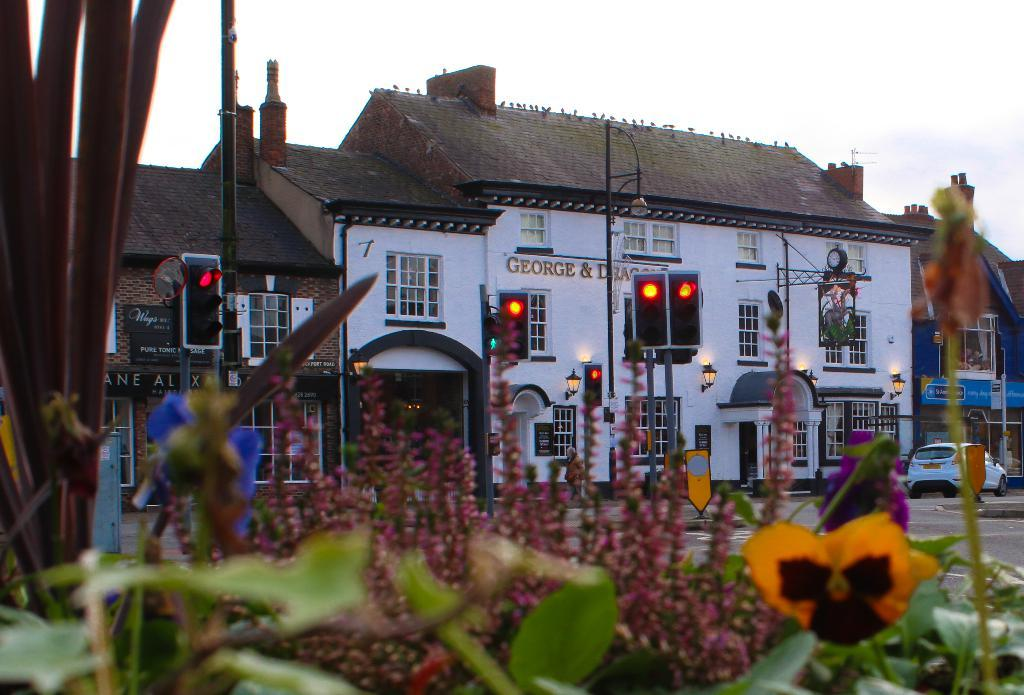What is the color of the house in the image? The house in the image is white. What features can be seen on the house? The house has windows and a rooftop. What is present at the bottom front side of the image? There are plants in the front bottom side of the image. How many babies are celebrating their birthday on the rooftop of the house in the image? There are no babies or birthday celebration present in the image. 